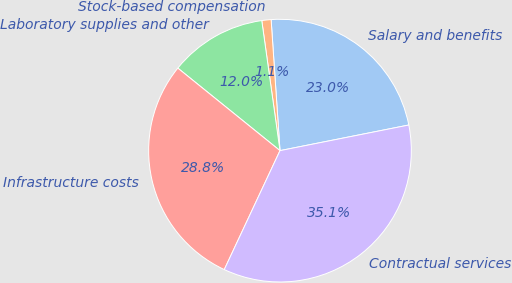<chart> <loc_0><loc_0><loc_500><loc_500><pie_chart><fcel>Salary and benefits<fcel>Stock-based compensation<fcel>Laboratory supplies and other<fcel>Infrastructure costs<fcel>Contractual services<nl><fcel>22.95%<fcel>1.14%<fcel>11.97%<fcel>28.84%<fcel>35.1%<nl></chart> 